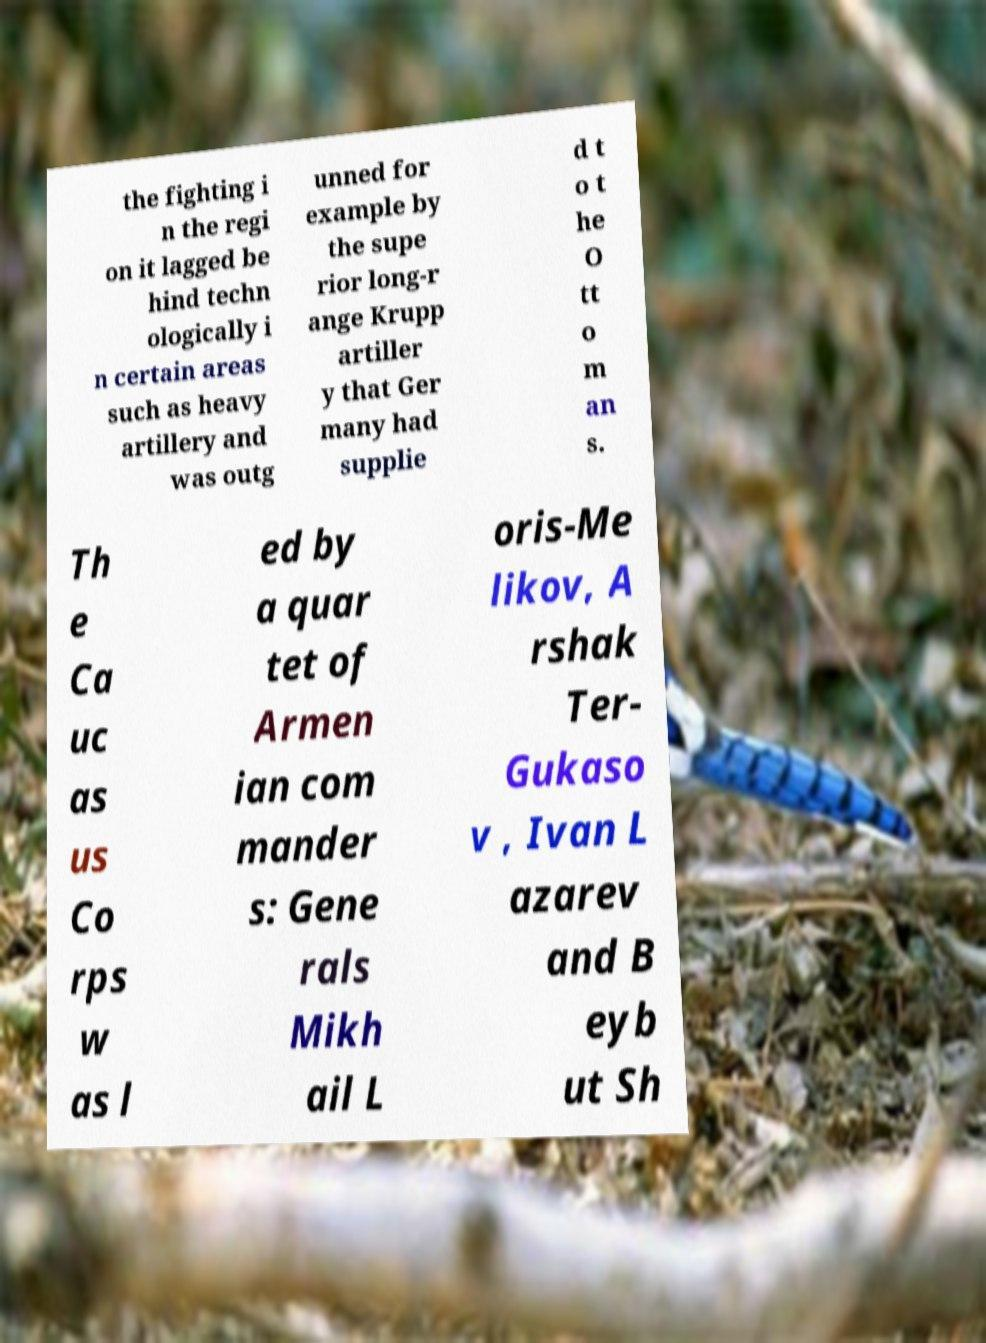I need the written content from this picture converted into text. Can you do that? the fighting i n the regi on it lagged be hind techn ologically i n certain areas such as heavy artillery and was outg unned for example by the supe rior long-r ange Krupp artiller y that Ger many had supplie d t o t he O tt o m an s. Th e Ca uc as us Co rps w as l ed by a quar tet of Armen ian com mander s: Gene rals Mikh ail L oris-Me likov, A rshak Ter- Gukaso v , Ivan L azarev and B eyb ut Sh 